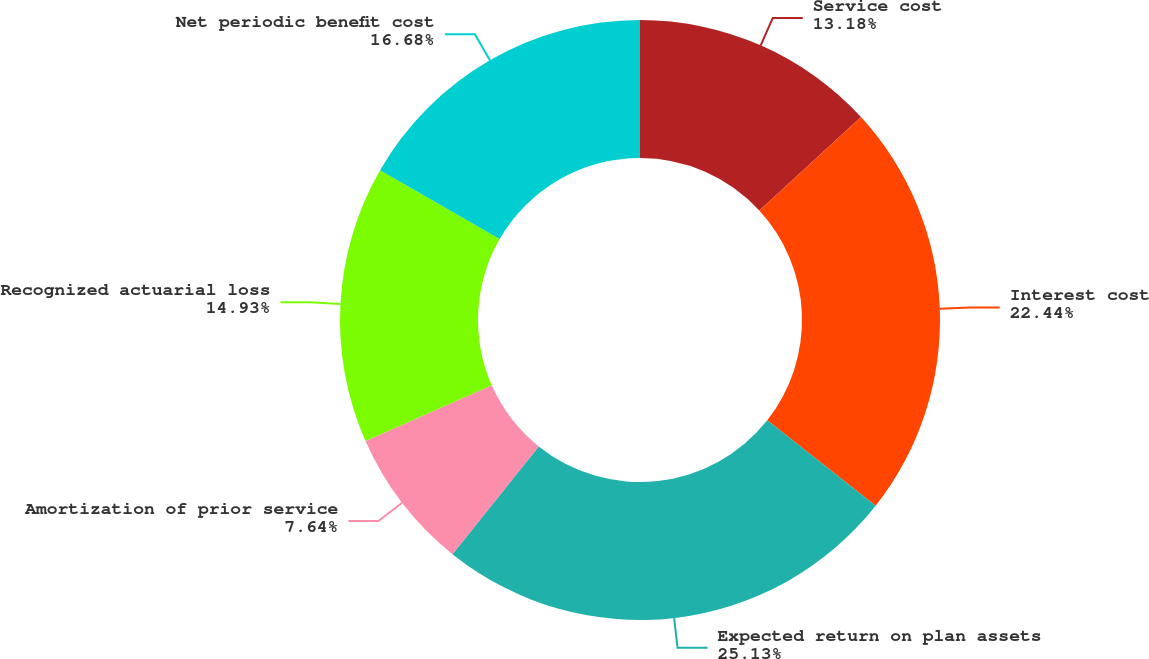Convert chart. <chart><loc_0><loc_0><loc_500><loc_500><pie_chart><fcel>Service cost<fcel>Interest cost<fcel>Expected return on plan assets<fcel>Amortization of prior service<fcel>Recognized actuarial loss<fcel>Net periodic benefit cost<nl><fcel>13.18%<fcel>22.44%<fcel>25.13%<fcel>7.64%<fcel>14.93%<fcel>16.68%<nl></chart> 